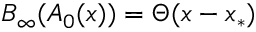<formula> <loc_0><loc_0><loc_500><loc_500>B _ { \infty } ( A _ { 0 } ( x ) ) = \Theta ( x - x _ { * } )</formula> 